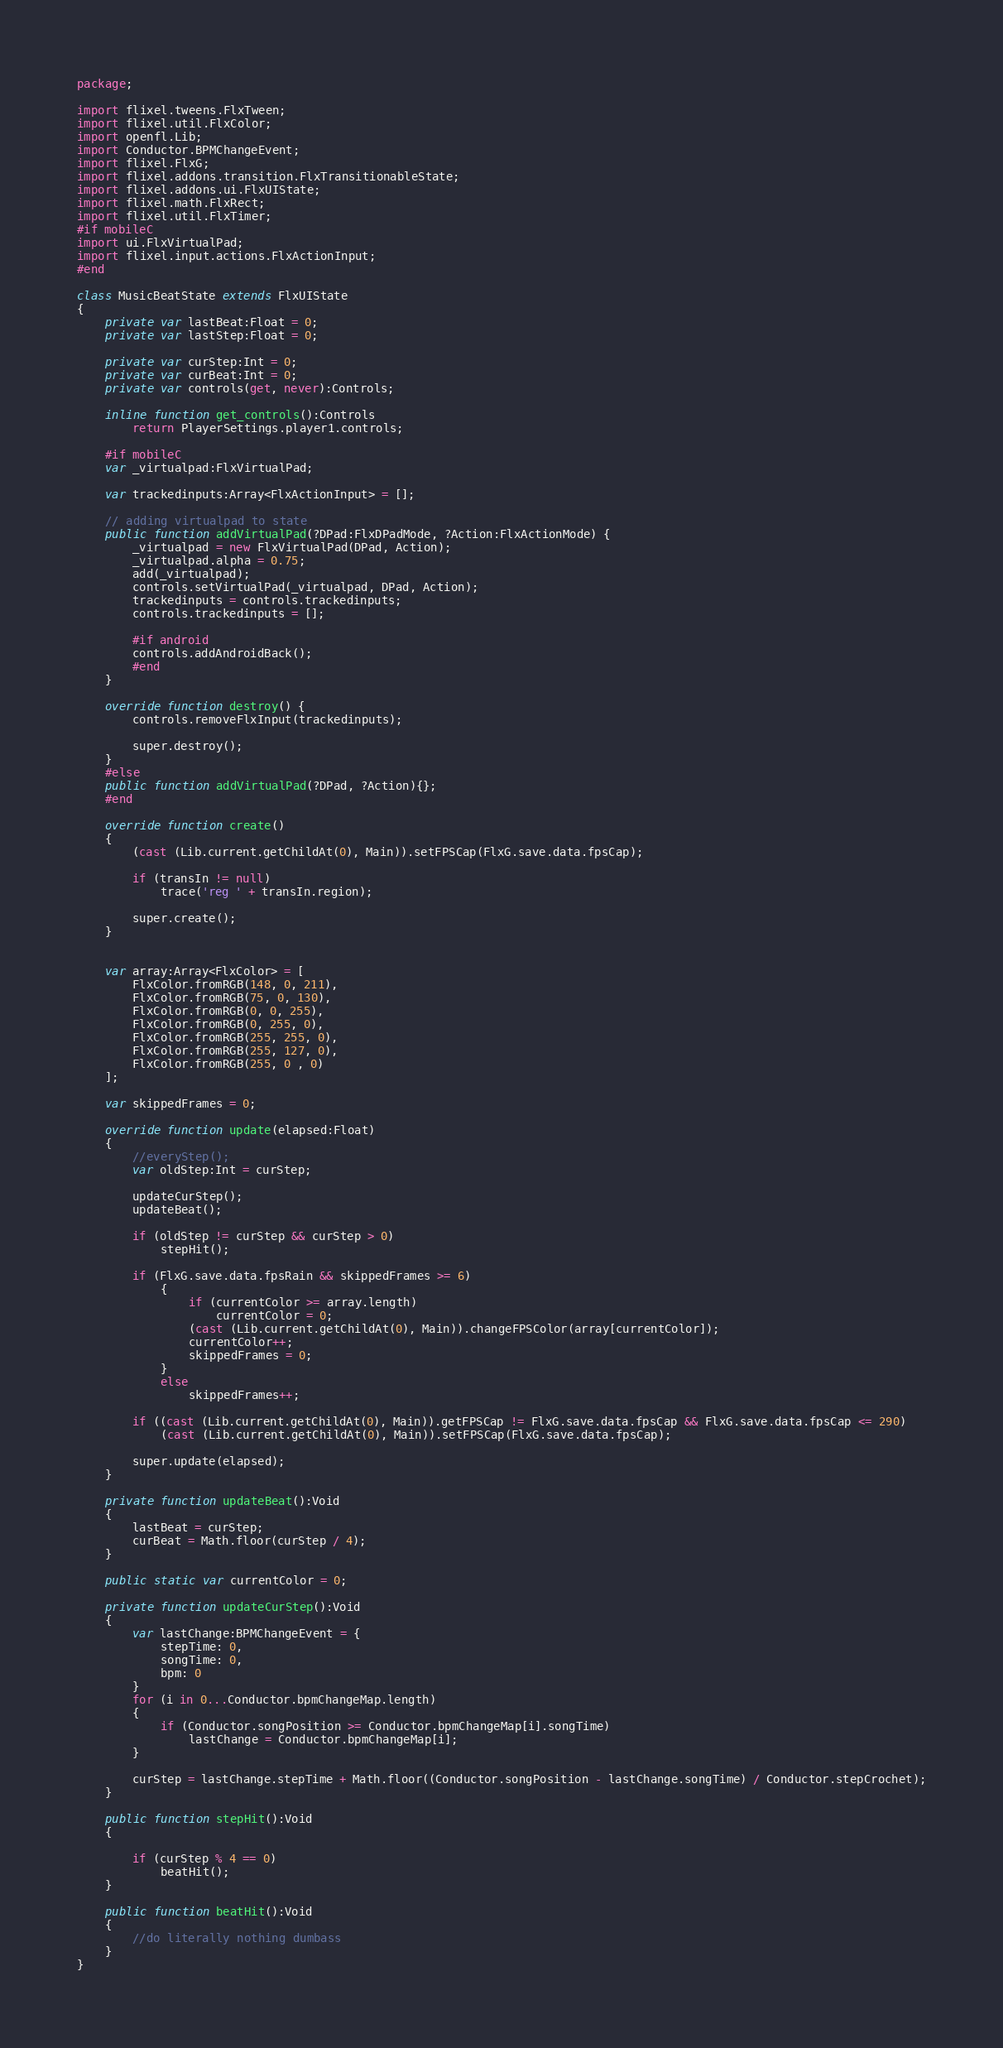Convert code to text. <code><loc_0><loc_0><loc_500><loc_500><_Haxe_>package;

import flixel.tweens.FlxTween;
import flixel.util.FlxColor;
import openfl.Lib;
import Conductor.BPMChangeEvent;
import flixel.FlxG;
import flixel.addons.transition.FlxTransitionableState;
import flixel.addons.ui.FlxUIState;
import flixel.math.FlxRect;
import flixel.util.FlxTimer;
#if mobileC
import ui.FlxVirtualPad;
import flixel.input.actions.FlxActionInput;
#end

class MusicBeatState extends FlxUIState
{
	private var lastBeat:Float = 0;
	private var lastStep:Float = 0;

	private var curStep:Int = 0;
	private var curBeat:Int = 0;
	private var controls(get, never):Controls;

	inline function get_controls():Controls
		return PlayerSettings.player1.controls;

	#if mobileC
	var _virtualpad:FlxVirtualPad;

	var trackedinputs:Array<FlxActionInput> = [];

	// adding virtualpad to state
	public function addVirtualPad(?DPad:FlxDPadMode, ?Action:FlxActionMode) {
		_virtualpad = new FlxVirtualPad(DPad, Action);
		_virtualpad.alpha = 0.75;
		add(_virtualpad);
		controls.setVirtualPad(_virtualpad, DPad, Action);
		trackedinputs = controls.trackedinputs;
		controls.trackedinputs = [];

		#if android
		controls.addAndroidBack();
		#end
	}
	
	override function destroy() {
		controls.removeFlxInput(trackedinputs);

		super.destroy();
	}
	#else
	public function addVirtualPad(?DPad, ?Action){};
	#end

	override function create()
	{
		(cast (Lib.current.getChildAt(0), Main)).setFPSCap(FlxG.save.data.fpsCap);

		if (transIn != null)
			trace('reg ' + transIn.region);

		super.create();
	}


	var array:Array<FlxColor> = [
		FlxColor.fromRGB(148, 0, 211),
		FlxColor.fromRGB(75, 0, 130),
		FlxColor.fromRGB(0, 0, 255),
		FlxColor.fromRGB(0, 255, 0),
		FlxColor.fromRGB(255, 255, 0),
		FlxColor.fromRGB(255, 127, 0),
		FlxColor.fromRGB(255, 0 , 0)
	];

	var skippedFrames = 0;

	override function update(elapsed:Float)
	{
		//everyStep();
		var oldStep:Int = curStep;

		updateCurStep();
		updateBeat();

		if (oldStep != curStep && curStep > 0)
			stepHit();

		if (FlxG.save.data.fpsRain && skippedFrames >= 6)
			{
				if (currentColor >= array.length)
					currentColor = 0;
				(cast (Lib.current.getChildAt(0), Main)).changeFPSColor(array[currentColor]);
				currentColor++;
				skippedFrames = 0;
			}
			else
				skippedFrames++;

		if ((cast (Lib.current.getChildAt(0), Main)).getFPSCap != FlxG.save.data.fpsCap && FlxG.save.data.fpsCap <= 290)
			(cast (Lib.current.getChildAt(0), Main)).setFPSCap(FlxG.save.data.fpsCap);

		super.update(elapsed);
	}

	private function updateBeat():Void
	{
		lastBeat = curStep;
		curBeat = Math.floor(curStep / 4);
	}

	public static var currentColor = 0;

	private function updateCurStep():Void
	{
		var lastChange:BPMChangeEvent = {
			stepTime: 0,
			songTime: 0,
			bpm: 0
		}
		for (i in 0...Conductor.bpmChangeMap.length)
		{
			if (Conductor.songPosition >= Conductor.bpmChangeMap[i].songTime)
				lastChange = Conductor.bpmChangeMap[i];
		}

		curStep = lastChange.stepTime + Math.floor((Conductor.songPosition - lastChange.songTime) / Conductor.stepCrochet);
	}

	public function stepHit():Void
	{

		if (curStep % 4 == 0)
			beatHit();
	}

	public function beatHit():Void
	{
		//do literally nothing dumbass
	}
}</code> 